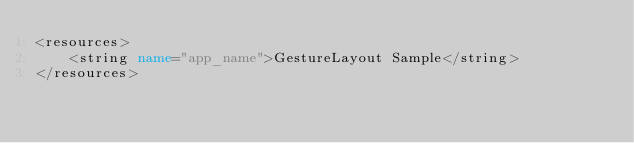<code> <loc_0><loc_0><loc_500><loc_500><_XML_><resources>
	<string name="app_name">GestureLayout Sample</string>
</resources>
</code> 